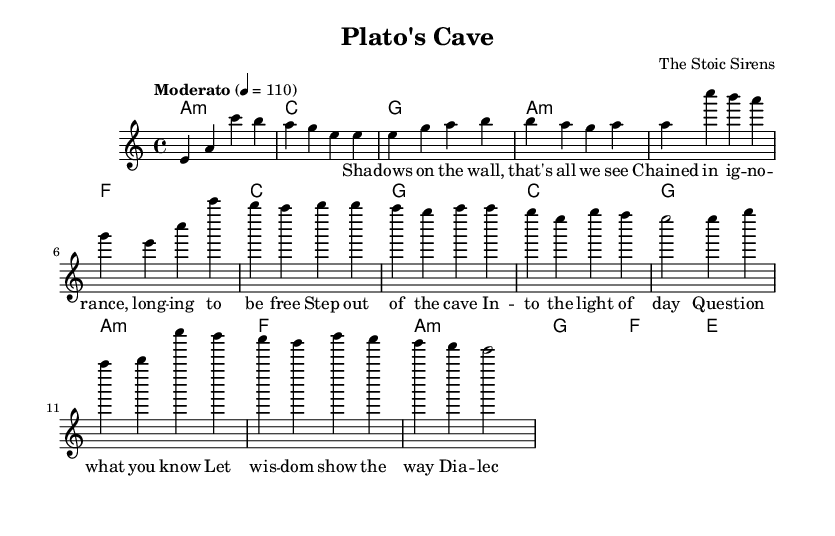What is the key signature of this music? The key signature shown in the music is A minor, which has no sharps or flats. A minor is the relative minor of C major, and its key signature is identical to C major without additional accidentals.
Answer: A minor What is the time signature of this music? The time signature present in the music is 4/4, indicating that there are four beats in a measure and the quarter note receives one beat. This can be confirmed by looking at the section at the beginning of the score.
Answer: 4/4 What is the tempo marking of this music? The tempo marking is "Moderato," which indicates a moderately paced tempo. The exact beats per minute are shown as 4 = 110, meaning there are 110 beats in one minute, with each beat represented by a quarter note.
Answer: Moderato How many measures are there in the chorus section? The chorus section consists of four measures, which can be determined by counting the notation blocks visually represented in that section of the music. Each measure is separated by a vertical bar line.
Answer: 4 What are the first three notes of the melody? The first three notes of the melody are E, A, and C, which can be found at the beginning of the melody line before any other notes are introduced. These notes form the initial motif of the song.
Answer: E, A, C Which philosopher's method is referenced in the lyrics? The lyrics reference the Socratic method, which is a form of dialectic questioning associated with the philosopher Socrates. This is indicated in the bridge section of the lyrics where 'Socratic method' is explicitly mentioned.
Answer: Socratic What type of harmony is primarily used in the first verse? The harmony used in the first verse is predominantly minor, particularly A minor, which sets a reflective tone appropriate for the themes presented in the lyrics. This can be inferred from the chord symbols accompanying the melody in that section.
Answer: Minor 